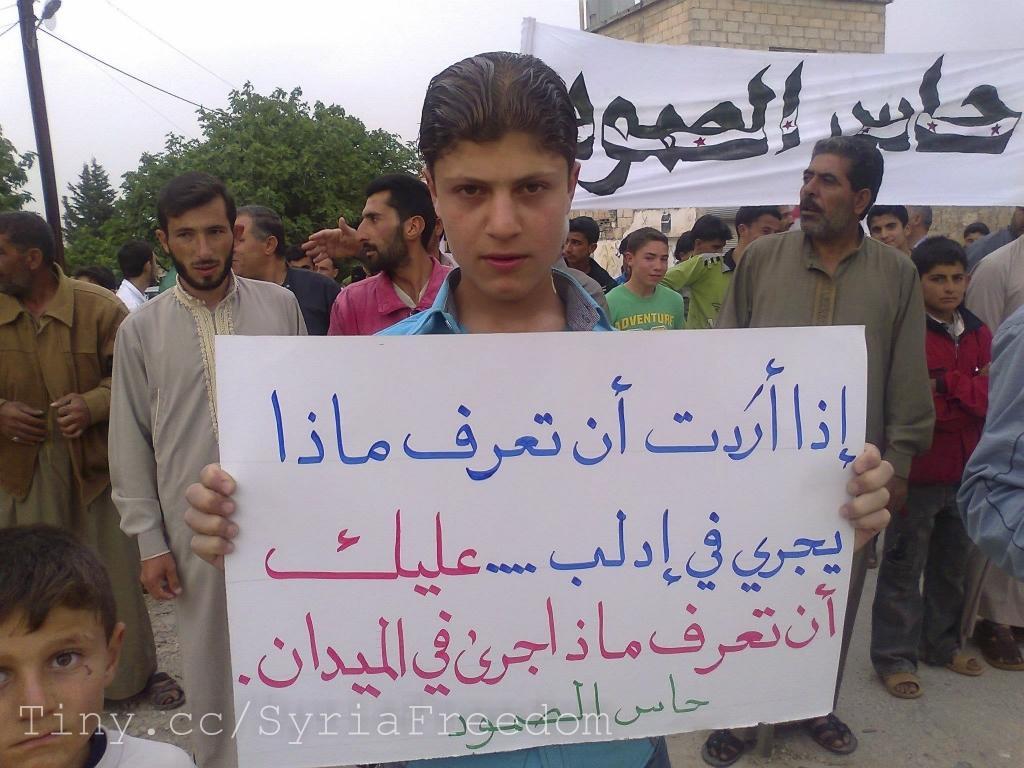Describe this image in one or two sentences. In this picture I can see a person holding the placard in the middle, at the bottom there is the watermark, there are group of people, on the right side I can see the cloth, on the left side there are trees, in the background there is a building, at the top I can see the sky. 